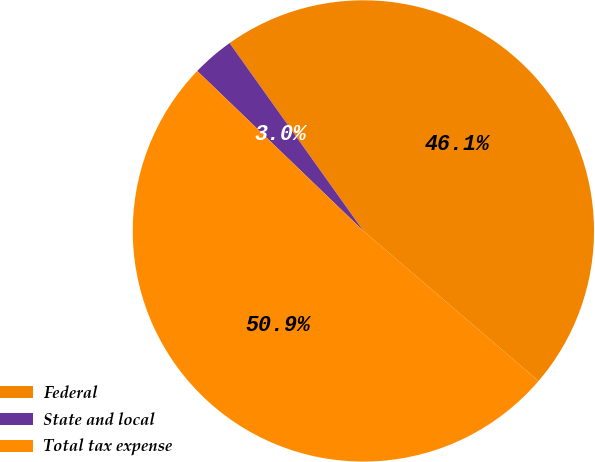Convert chart. <chart><loc_0><loc_0><loc_500><loc_500><pie_chart><fcel>Federal<fcel>State and local<fcel>Total tax expense<nl><fcel>46.13%<fcel>2.95%<fcel>50.92%<nl></chart> 